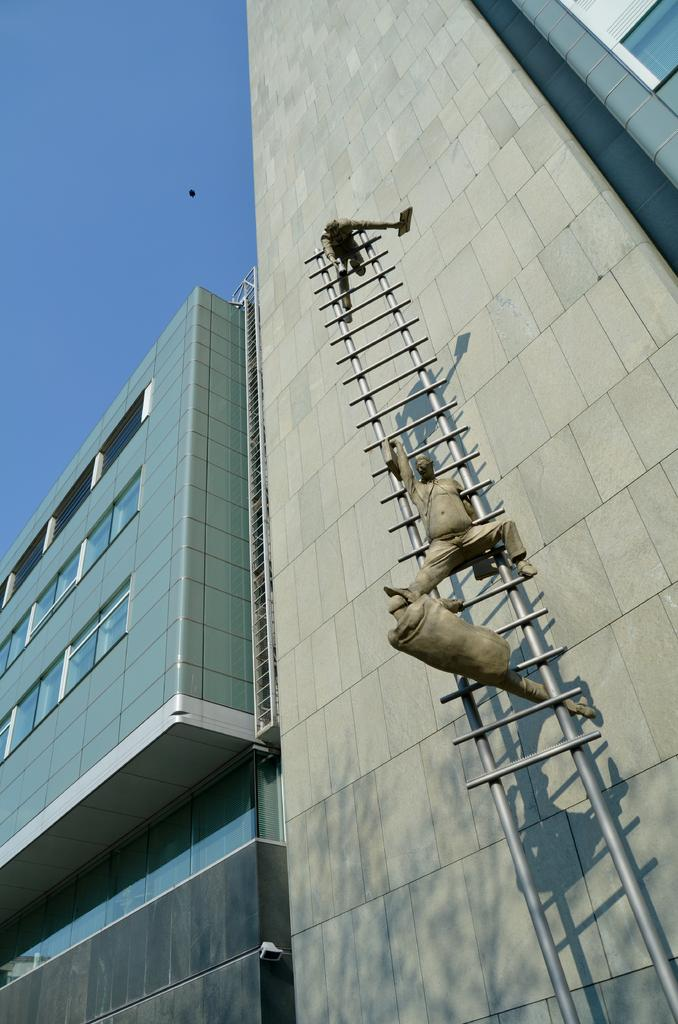What type of structures can be seen in the image? There are buildings in the image. What other object is present in the image besides the buildings? There is a statue in the image. How is the statue positioned in relation to the buildings? The statue is on a ladder. What part of the sky can be seen in the image? The sky is visible in the top left of the image. What is the name of the plant growing near the statue? There is no plant visible near the statue in the image. 